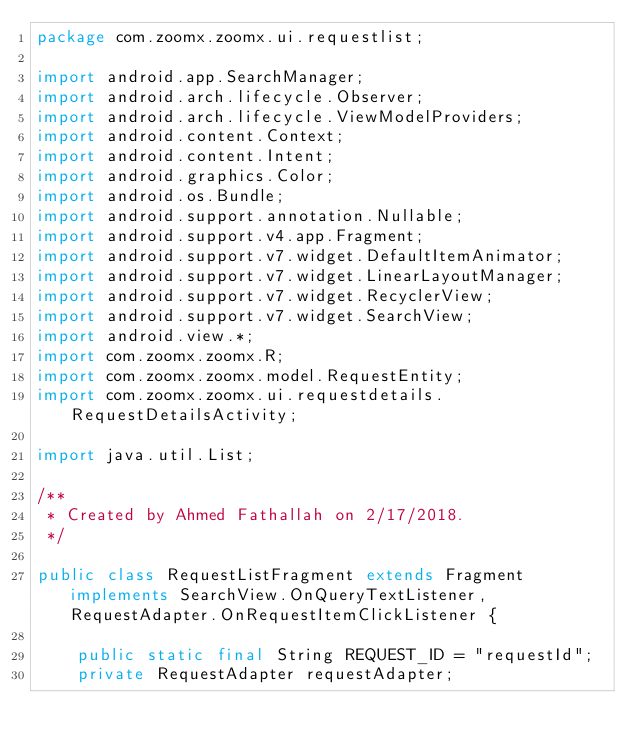Convert code to text. <code><loc_0><loc_0><loc_500><loc_500><_Java_>package com.zoomx.zoomx.ui.requestlist;

import android.app.SearchManager;
import android.arch.lifecycle.Observer;
import android.arch.lifecycle.ViewModelProviders;
import android.content.Context;
import android.content.Intent;
import android.graphics.Color;
import android.os.Bundle;
import android.support.annotation.Nullable;
import android.support.v4.app.Fragment;
import android.support.v7.widget.DefaultItemAnimator;
import android.support.v7.widget.LinearLayoutManager;
import android.support.v7.widget.RecyclerView;
import android.support.v7.widget.SearchView;
import android.view.*;
import com.zoomx.zoomx.R;
import com.zoomx.zoomx.model.RequestEntity;
import com.zoomx.zoomx.ui.requestdetails.RequestDetailsActivity;

import java.util.List;

/**
 * Created by Ahmed Fathallah on 2/17/2018.
 */

public class RequestListFragment extends Fragment implements SearchView.OnQueryTextListener, RequestAdapter.OnRequestItemClickListener {

    public static final String REQUEST_ID = "requestId";
    private RequestAdapter requestAdapter;</code> 